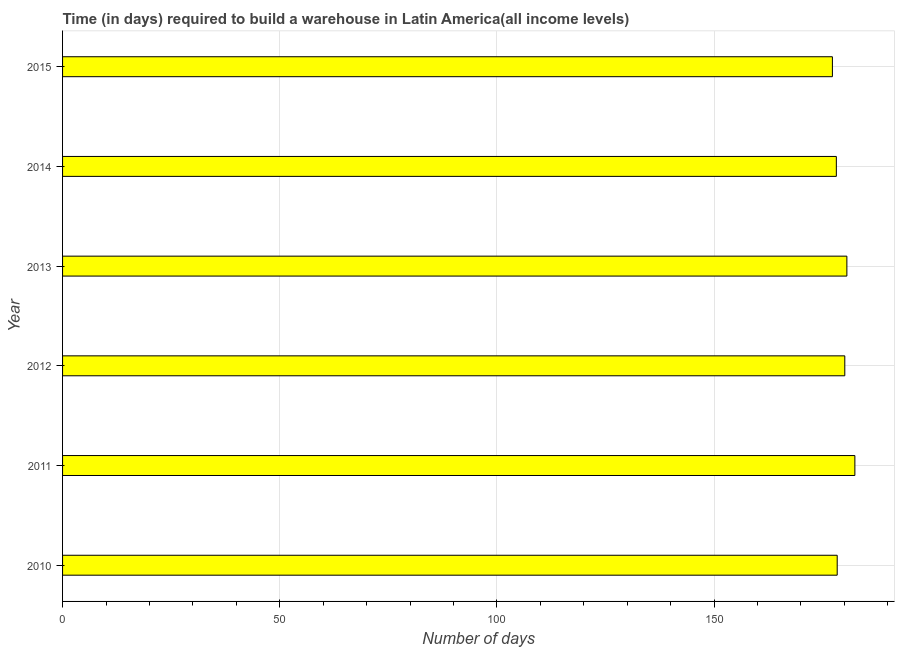Does the graph contain any zero values?
Ensure brevity in your answer.  No. What is the title of the graph?
Make the answer very short. Time (in days) required to build a warehouse in Latin America(all income levels). What is the label or title of the X-axis?
Keep it short and to the point. Number of days. What is the time required to build a warehouse in 2013?
Offer a very short reply. 180.59. Across all years, what is the maximum time required to build a warehouse?
Provide a succinct answer. 182.44. Across all years, what is the minimum time required to build a warehouse?
Your response must be concise. 177.26. In which year was the time required to build a warehouse minimum?
Give a very brief answer. 2015. What is the sum of the time required to build a warehouse?
Provide a short and direct response. 1076.94. What is the difference between the time required to build a warehouse in 2011 and 2013?
Your answer should be compact. 1.84. What is the average time required to build a warehouse per year?
Offer a very short reply. 179.49. What is the median time required to build a warehouse?
Make the answer very short. 179.24. In how many years, is the time required to build a warehouse greater than 150 days?
Provide a short and direct response. 6. Is the time required to build a warehouse in 2011 less than that in 2012?
Ensure brevity in your answer.  No. What is the difference between the highest and the second highest time required to build a warehouse?
Keep it short and to the point. 1.84. Is the sum of the time required to build a warehouse in 2011 and 2015 greater than the maximum time required to build a warehouse across all years?
Ensure brevity in your answer.  Yes. What is the difference between the highest and the lowest time required to build a warehouse?
Keep it short and to the point. 5.17. In how many years, is the time required to build a warehouse greater than the average time required to build a warehouse taken over all years?
Make the answer very short. 3. How many years are there in the graph?
Provide a short and direct response. 6. What is the difference between two consecutive major ticks on the X-axis?
Offer a terse response. 50. What is the Number of days in 2010?
Offer a terse response. 178.37. What is the Number of days of 2011?
Offer a very short reply. 182.44. What is the Number of days of 2012?
Make the answer very short. 180.11. What is the Number of days in 2013?
Your answer should be compact. 180.59. What is the Number of days of 2014?
Provide a succinct answer. 178.17. What is the Number of days of 2015?
Offer a terse response. 177.26. What is the difference between the Number of days in 2010 and 2011?
Your answer should be very brief. -4.07. What is the difference between the Number of days in 2010 and 2012?
Your answer should be compact. -1.75. What is the difference between the Number of days in 2010 and 2013?
Your answer should be very brief. -2.23. What is the difference between the Number of days in 2010 and 2014?
Provide a short and direct response. 0.2. What is the difference between the Number of days in 2010 and 2015?
Your response must be concise. 1.11. What is the difference between the Number of days in 2011 and 2012?
Offer a very short reply. 2.32. What is the difference between the Number of days in 2011 and 2013?
Your answer should be compact. 1.84. What is the difference between the Number of days in 2011 and 2014?
Your response must be concise. 4.27. What is the difference between the Number of days in 2011 and 2015?
Keep it short and to the point. 5.17. What is the difference between the Number of days in 2012 and 2013?
Your answer should be compact. -0.48. What is the difference between the Number of days in 2012 and 2014?
Provide a succinct answer. 1.94. What is the difference between the Number of days in 2012 and 2015?
Make the answer very short. 2.85. What is the difference between the Number of days in 2013 and 2014?
Keep it short and to the point. 2.42. What is the difference between the Number of days in 2013 and 2015?
Your answer should be compact. 3.33. What is the difference between the Number of days in 2014 and 2015?
Your answer should be very brief. 0.91. What is the ratio of the Number of days in 2010 to that in 2012?
Provide a succinct answer. 0.99. What is the ratio of the Number of days in 2010 to that in 2014?
Ensure brevity in your answer.  1. What is the ratio of the Number of days in 2010 to that in 2015?
Your response must be concise. 1.01. What is the ratio of the Number of days in 2011 to that in 2013?
Make the answer very short. 1.01. What is the ratio of the Number of days in 2011 to that in 2014?
Your answer should be very brief. 1.02. What is the ratio of the Number of days in 2012 to that in 2013?
Make the answer very short. 1. What is the ratio of the Number of days in 2012 to that in 2014?
Provide a succinct answer. 1.01. What is the ratio of the Number of days in 2014 to that in 2015?
Provide a short and direct response. 1. 